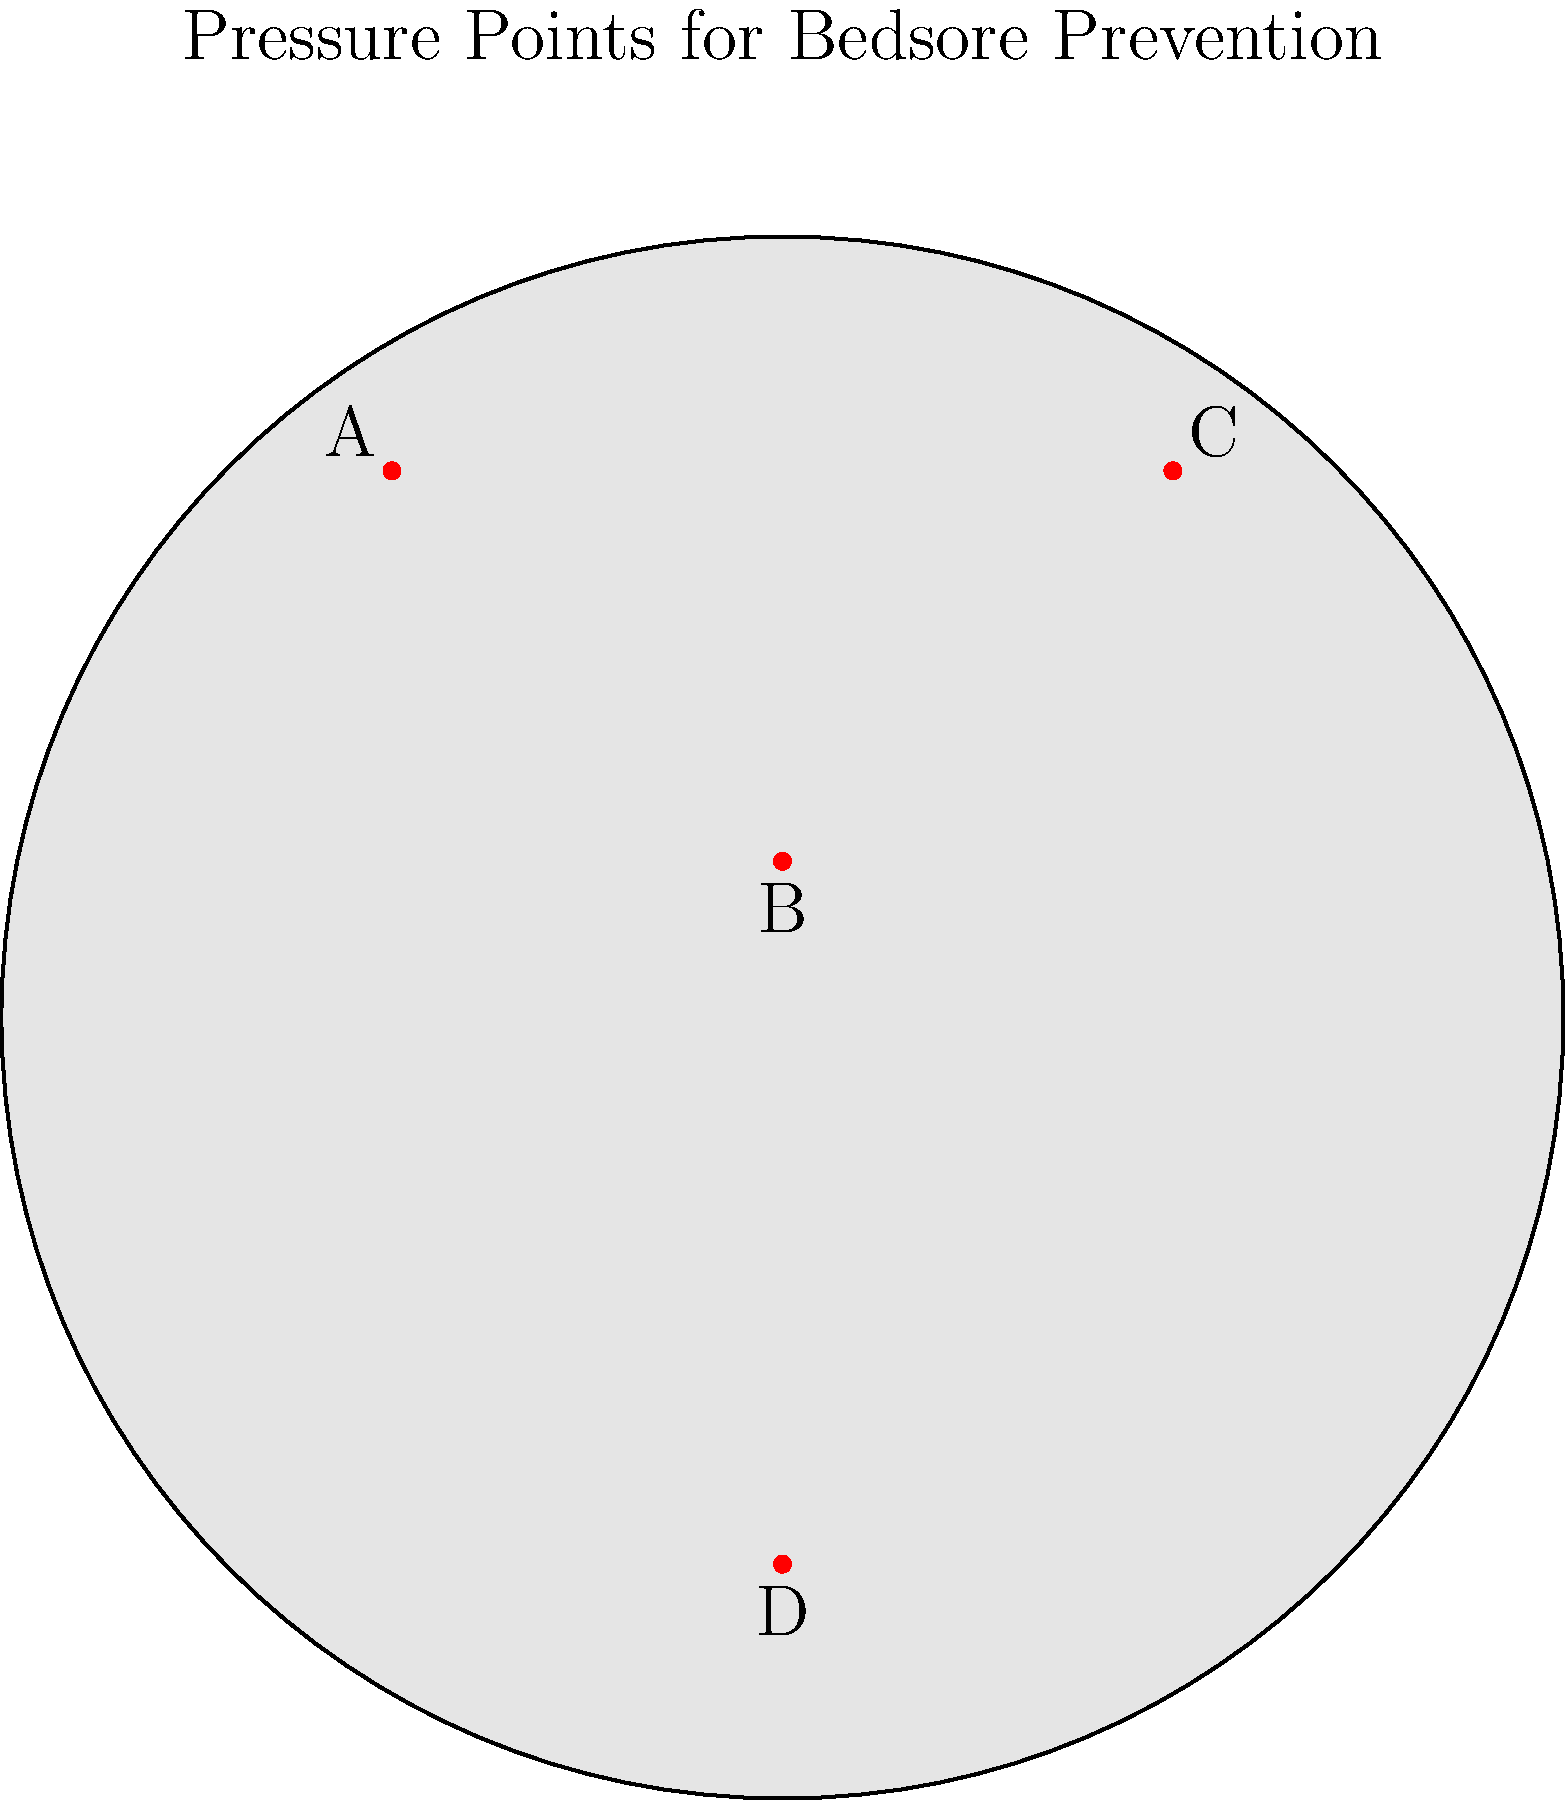Based on the human body diagram, which pressure point is most likely to develop a bedsore in a patient who is primarily in a supine position (lying on their back)? To answer this question, we need to consider the following steps:

1. Understand the supine position: This is when a patient is lying flat on their back.

2. Identify pressure points in the supine position:
   - Point A: Corresponds to the shoulder blade area
   - Point B: Corresponds to the sacral area (lower back)
   - Point C: Corresponds to the other shoulder blade area
   - Point D: Corresponds to the heel area

3. Assess risk factors for bedsores:
   - Pressure points that bear the most weight in a given position are at highest risk
   - Areas with less padding (less flesh between bone and skin) are more vulnerable

4. Evaluate each point:
   - Points A and C (shoulder blades): While they do bear some weight, they have more muscle padding than other areas.
   - Point B (sacral area): This area bears significant weight in the supine position and has less natural padding.
   - Point D (heel): While at risk, it typically bears less weight than the sacral area in the supine position.

5. Conclusion: The sacral area (Point B) is most likely to develop a bedsore in the supine position due to the combination of weight-bearing and less natural padding in this area.
Answer: B (sacral area) 